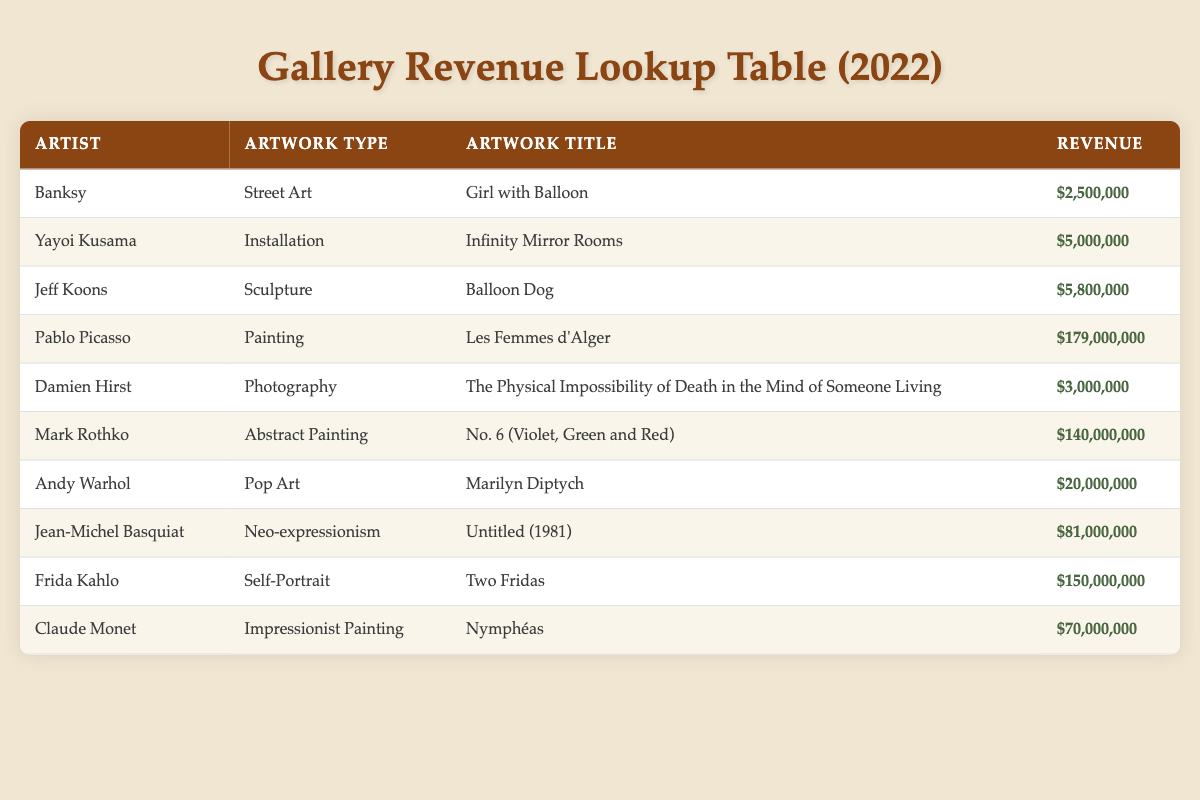What is the highest revenue generated by a single artwork in 2022? The highest revenue in the table is associated with Pablo Picasso's "Les Femmes d'Alger," which generated $179,000,000. This can be found by scanning through the Revenue column for the maximum value.
Answer: $179,000,000 How much revenue did Frida Kahlo's artwork generate compared to Andy Warhol's? Frida Kahlo's artwork "Two Fridas" made $150,000,000, whereas Andy Warhol's "Marilyn Diptych" generated $20,000,000. To find the difference, subtract Warhol's revenue from Kahlo's: $150,000,000 - $20,000,000 = $130,000,000.
Answer: $130,000,000 Did any artist generate more than $100,000,000 in revenue in 2022? By checking the Revenue column, both Pablo Picasso and Mark Rothko have revenue figures that exceed $100,000,000 ($179,000,000 and $140,000,000, respectively). Thus, the statement is true.
Answer: Yes What is the total revenue generated by artworks classified as "Painting" in 2022? The total revenue from painting includes "Les Femmes d'Alger" by Pablo Picasso ($179,000,000) and "Two Fridas" by Frida Kahlo ($150,000,000). Adding these figures together: $179,000,000 + $150,000,000 = $329,000,000.
Answer: $329,000,000 Which artist had the lowest revenue, and what was the amount? The artist with the lowest revenue is Banksy, whose artwork "Girl with Balloon" generated $2,500,000. This is found by scanning through the Revenue column for the minimum value.
Answer: $2,500,000 What is the average revenue of all artworks by Jeff Koons? Jeff Koons only has one entry, "Balloon Dog," with a revenue of $5,800,000. Therefore, the average revenue is simply equal to this single revenue figure, as there are no other works by him included.
Answer: $5,800,000 How much more revenue did Yayoi Kusama's "Infinity Mirror Rooms" generate than Damien Hirst's photography? Yayoi Kusama's "Infinity Mirror Rooms" generated $5,000,000, while Damien Hirst's photography made $3,000,000. To find the difference: $5,000,000 - $3,000,000 = $2,000,000.
Answer: $2,000,000 Is it true that Jean-Michel Basquiat's revenue is greater than 80 million dollars? Jean-Michel Basquiat's artwork "Untitled (1981)" generated $81,000,000, which is indeed greater than 80 million dollars. Therefore, the statement is true.
Answer: Yes What is the total revenue generated by all artworks included in the table? The total revenue can be calculated by summing the revenues from each artist's artwork. The individual revenues are: $2,500,000 + $5,000,000 + $5,800,000 + $179,000,000 + $3,000,000 + $140,000,000 + $20,000,000 + $81,000,000 + $150,000,000 + $70,000,000, which totals $442,300,000.
Answer: $442,300,000 